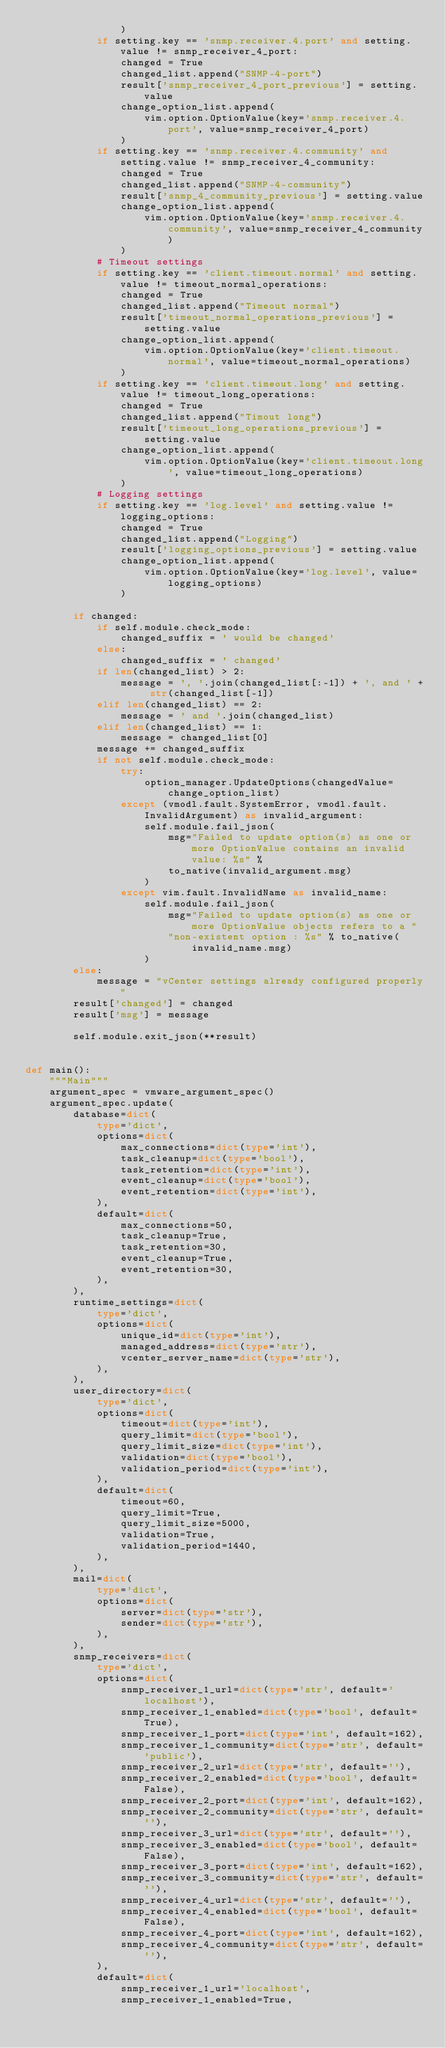Convert code to text. <code><loc_0><loc_0><loc_500><loc_500><_Python_>                )
            if setting.key == 'snmp.receiver.4.port' and setting.value != snmp_receiver_4_port:
                changed = True
                changed_list.append("SNMP-4-port")
                result['snmp_receiver_4_port_previous'] = setting.value
                change_option_list.append(
                    vim.option.OptionValue(key='snmp.receiver.4.port', value=snmp_receiver_4_port)
                )
            if setting.key == 'snmp.receiver.4.community' and setting.value != snmp_receiver_4_community:
                changed = True
                changed_list.append("SNMP-4-community")
                result['snmp_4_community_previous'] = setting.value
                change_option_list.append(
                    vim.option.OptionValue(key='snmp.receiver.4.community', value=snmp_receiver_4_community)
                )
            # Timeout settings
            if setting.key == 'client.timeout.normal' and setting.value != timeout_normal_operations:
                changed = True
                changed_list.append("Timeout normal")
                result['timeout_normal_operations_previous'] = setting.value
                change_option_list.append(
                    vim.option.OptionValue(key='client.timeout.normal', value=timeout_normal_operations)
                )
            if setting.key == 'client.timeout.long' and setting.value != timeout_long_operations:
                changed = True
                changed_list.append("Timout long")
                result['timeout_long_operations_previous'] = setting.value
                change_option_list.append(
                    vim.option.OptionValue(key='client.timeout.long', value=timeout_long_operations)
                )
            # Logging settings
            if setting.key == 'log.level' and setting.value != logging_options:
                changed = True
                changed_list.append("Logging")
                result['logging_options_previous'] = setting.value
                change_option_list.append(
                    vim.option.OptionValue(key='log.level', value=logging_options)
                )

        if changed:
            if self.module.check_mode:
                changed_suffix = ' would be changed'
            else:
                changed_suffix = ' changed'
            if len(changed_list) > 2:
                message = ', '.join(changed_list[:-1]) + ', and ' + str(changed_list[-1])
            elif len(changed_list) == 2:
                message = ' and '.join(changed_list)
            elif len(changed_list) == 1:
                message = changed_list[0]
            message += changed_suffix
            if not self.module.check_mode:
                try:
                    option_manager.UpdateOptions(changedValue=change_option_list)
                except (vmodl.fault.SystemError, vmodl.fault.InvalidArgument) as invalid_argument:
                    self.module.fail_json(
                        msg="Failed to update option(s) as one or more OptionValue contains an invalid value: %s" %
                        to_native(invalid_argument.msg)
                    )
                except vim.fault.InvalidName as invalid_name:
                    self.module.fail_json(
                        msg="Failed to update option(s) as one or more OptionValue objects refers to a "
                        "non-existent option : %s" % to_native(invalid_name.msg)
                    )
        else:
            message = "vCenter settings already configured properly"
        result['changed'] = changed
        result['msg'] = message

        self.module.exit_json(**result)


def main():
    """Main"""
    argument_spec = vmware_argument_spec()
    argument_spec.update(
        database=dict(
            type='dict',
            options=dict(
                max_connections=dict(type='int'),
                task_cleanup=dict(type='bool'),
                task_retention=dict(type='int'),
                event_cleanup=dict(type='bool'),
                event_retention=dict(type='int'),
            ),
            default=dict(
                max_connections=50,
                task_cleanup=True,
                task_retention=30,
                event_cleanup=True,
                event_retention=30,
            ),
        ),
        runtime_settings=dict(
            type='dict',
            options=dict(
                unique_id=dict(type='int'),
                managed_address=dict(type='str'),
                vcenter_server_name=dict(type='str'),
            ),
        ),
        user_directory=dict(
            type='dict',
            options=dict(
                timeout=dict(type='int'),
                query_limit=dict(type='bool'),
                query_limit_size=dict(type='int'),
                validation=dict(type='bool'),
                validation_period=dict(type='int'),
            ),
            default=dict(
                timeout=60,
                query_limit=True,
                query_limit_size=5000,
                validation=True,
                validation_period=1440,
            ),
        ),
        mail=dict(
            type='dict',
            options=dict(
                server=dict(type='str'),
                sender=dict(type='str'),
            ),
        ),
        snmp_receivers=dict(
            type='dict',
            options=dict(
                snmp_receiver_1_url=dict(type='str', default='localhost'),
                snmp_receiver_1_enabled=dict(type='bool', default=True),
                snmp_receiver_1_port=dict(type='int', default=162),
                snmp_receiver_1_community=dict(type='str', default='public'),
                snmp_receiver_2_url=dict(type='str', default=''),
                snmp_receiver_2_enabled=dict(type='bool', default=False),
                snmp_receiver_2_port=dict(type='int', default=162),
                snmp_receiver_2_community=dict(type='str', default=''),
                snmp_receiver_3_url=dict(type='str', default=''),
                snmp_receiver_3_enabled=dict(type='bool', default=False),
                snmp_receiver_3_port=dict(type='int', default=162),
                snmp_receiver_3_community=dict(type='str', default=''),
                snmp_receiver_4_url=dict(type='str', default=''),
                snmp_receiver_4_enabled=dict(type='bool', default=False),
                snmp_receiver_4_port=dict(type='int', default=162),
                snmp_receiver_4_community=dict(type='str', default=''),
            ),
            default=dict(
                snmp_receiver_1_url='localhost',
                snmp_receiver_1_enabled=True,</code> 